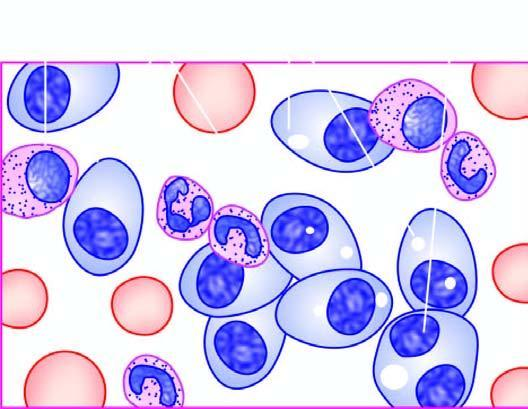does peripheral blood film show marked neutrophilic leucocytosis aspirate in myeloma showing numerous plasma cells, many with abnormal features?
Answer the question using a single word or phrase. No 